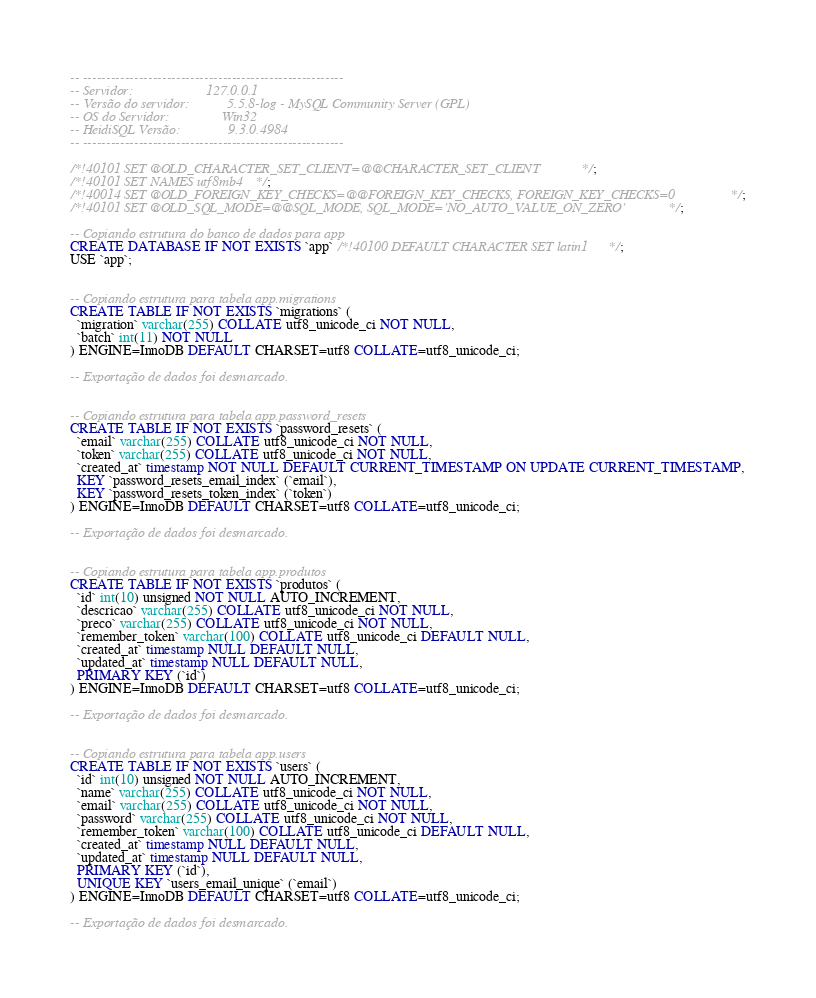<code> <loc_0><loc_0><loc_500><loc_500><_SQL_>-- --------------------------------------------------------
-- Servidor:                     127.0.0.1
-- Versão do servidor:           5.5.8-log - MySQL Community Server (GPL)
-- OS do Servidor:               Win32
-- HeidiSQL Versão:              9.3.0.4984
-- --------------------------------------------------------

/*!40101 SET @OLD_CHARACTER_SET_CLIENT=@@CHARACTER_SET_CLIENT */;
/*!40101 SET NAMES utf8mb4 */;
/*!40014 SET @OLD_FOREIGN_KEY_CHECKS=@@FOREIGN_KEY_CHECKS, FOREIGN_KEY_CHECKS=0 */;
/*!40101 SET @OLD_SQL_MODE=@@SQL_MODE, SQL_MODE='NO_AUTO_VALUE_ON_ZERO' */;

-- Copiando estrutura do banco de dados para app
CREATE DATABASE IF NOT EXISTS `app` /*!40100 DEFAULT CHARACTER SET latin1 */;
USE `app`;


-- Copiando estrutura para tabela app.migrations
CREATE TABLE IF NOT EXISTS `migrations` (
  `migration` varchar(255) COLLATE utf8_unicode_ci NOT NULL,
  `batch` int(11) NOT NULL
) ENGINE=InnoDB DEFAULT CHARSET=utf8 COLLATE=utf8_unicode_ci;

-- Exportação de dados foi desmarcado.


-- Copiando estrutura para tabela app.password_resets
CREATE TABLE IF NOT EXISTS `password_resets` (
  `email` varchar(255) COLLATE utf8_unicode_ci NOT NULL,
  `token` varchar(255) COLLATE utf8_unicode_ci NOT NULL,
  `created_at` timestamp NOT NULL DEFAULT CURRENT_TIMESTAMP ON UPDATE CURRENT_TIMESTAMP,
  KEY `password_resets_email_index` (`email`),
  KEY `password_resets_token_index` (`token`)
) ENGINE=InnoDB DEFAULT CHARSET=utf8 COLLATE=utf8_unicode_ci;

-- Exportação de dados foi desmarcado.


-- Copiando estrutura para tabela app.produtos
CREATE TABLE IF NOT EXISTS `produtos` (
  `id` int(10) unsigned NOT NULL AUTO_INCREMENT,
  `descricao` varchar(255) COLLATE utf8_unicode_ci NOT NULL,
  `preco` varchar(255) COLLATE utf8_unicode_ci NOT NULL,
  `remember_token` varchar(100) COLLATE utf8_unicode_ci DEFAULT NULL,
  `created_at` timestamp NULL DEFAULT NULL,
  `updated_at` timestamp NULL DEFAULT NULL,
  PRIMARY KEY (`id`)
) ENGINE=InnoDB DEFAULT CHARSET=utf8 COLLATE=utf8_unicode_ci;

-- Exportação de dados foi desmarcado.


-- Copiando estrutura para tabela app.users
CREATE TABLE IF NOT EXISTS `users` (
  `id` int(10) unsigned NOT NULL AUTO_INCREMENT,
  `name` varchar(255) COLLATE utf8_unicode_ci NOT NULL,
  `email` varchar(255) COLLATE utf8_unicode_ci NOT NULL,
  `password` varchar(255) COLLATE utf8_unicode_ci NOT NULL,
  `remember_token` varchar(100) COLLATE utf8_unicode_ci DEFAULT NULL,
  `created_at` timestamp NULL DEFAULT NULL,
  `updated_at` timestamp NULL DEFAULT NULL,
  PRIMARY KEY (`id`),
  UNIQUE KEY `users_email_unique` (`email`)
) ENGINE=InnoDB DEFAULT CHARSET=utf8 COLLATE=utf8_unicode_ci;

-- Exportação de dados foi desmarcado.</code> 